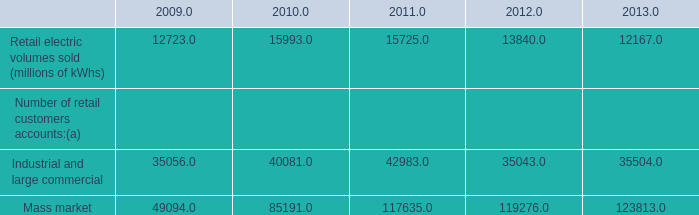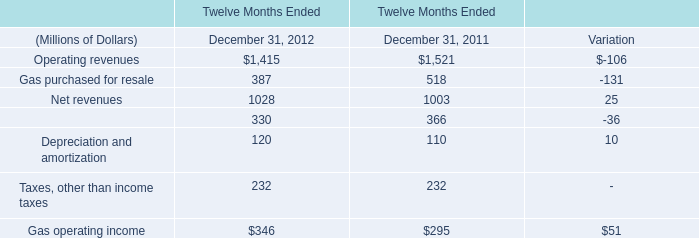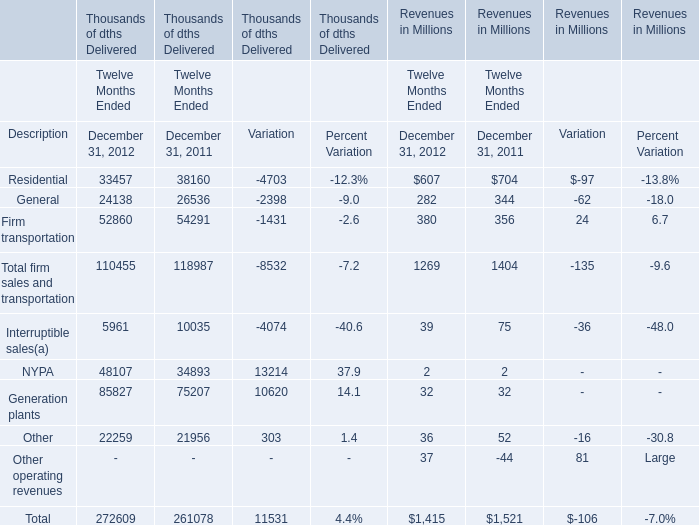How many elements' value in 2012 are lower than the previous year? 
Answer: 3. 